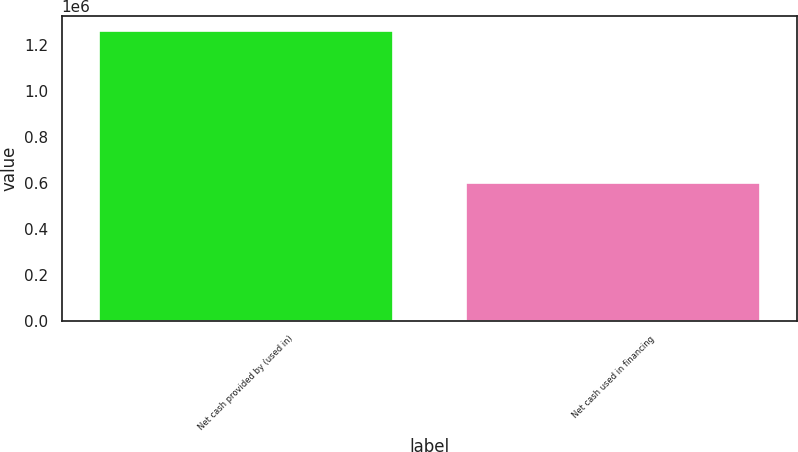<chart> <loc_0><loc_0><loc_500><loc_500><bar_chart><fcel>Net cash provided by (used in)<fcel>Net cash used in financing<nl><fcel>1.26226e+06<fcel>601254<nl></chart> 